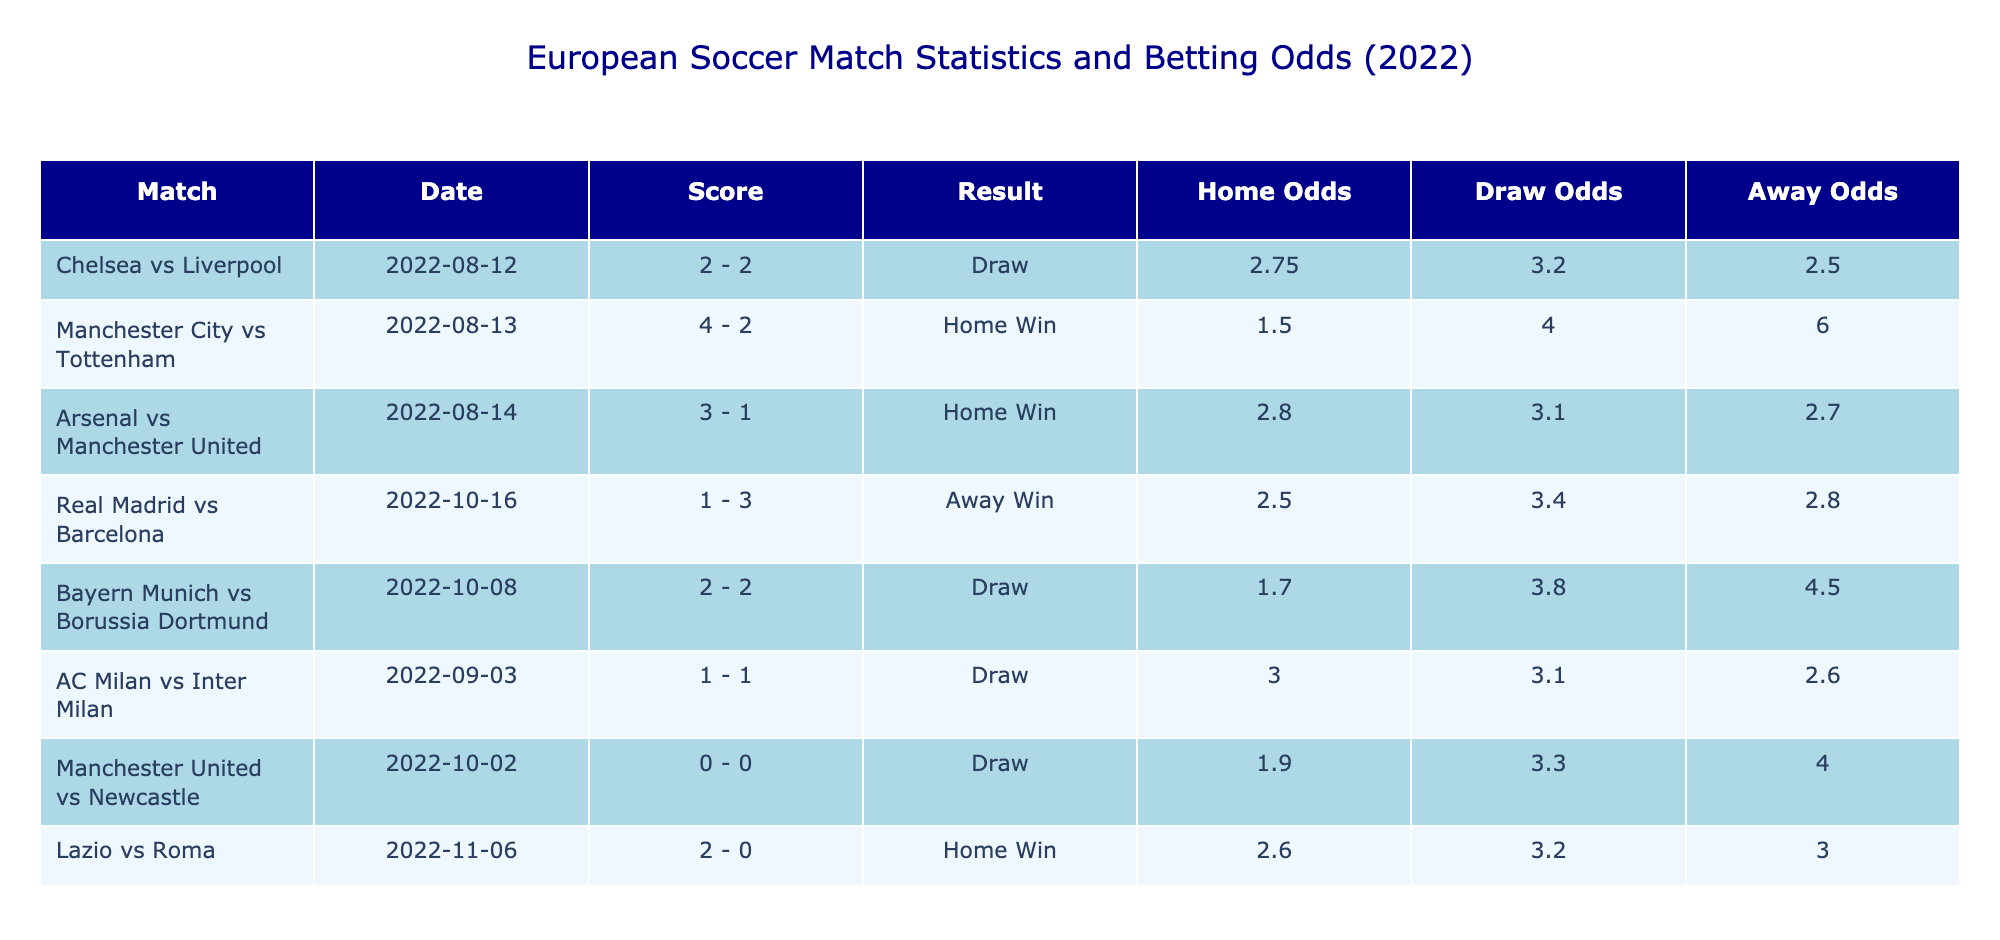What's the score of the match between Chelsea and Liverpool? The table shows the match "Chelsea vs Liverpool" with the home team scoring 2 goals and the away team also scoring 2 goals. Hence, the score is 2 - 2.
Answer: 2 - 2 Which match had the highest home odds? By reviewing the "Home Odds" column, the highest value is 3.00 for the match between AC Milan and Inter Milan.
Answer: 3.00 How many matches ended in a draw? Looking at the "Result" column, there are two matches that ended in a draw: Chelsea vs Liverpool and AC Milan vs Inter Milan.
Answer: 2 What is the average away odds of all the matches listed? To find the average away odds, sum the away odds (2.50 + 6.00 + 2.70 + 2.80 + 4.50 + 2.60 + 4.00 + 3.00) which totals 28.10, then divide by the number of matches (8): 28.10 / 8 = 3.51.
Answer: 3.51 Did Manchester City win against Tottenham? The result for "Manchester City vs Tottenham" shows the home team scored 4 goals while the away team scored 2 goals. Therefore, Manchester City won the match.
Answer: Yes What is the result of the match between Lazio and Roma? In the table, the match "Lazio vs Roma" shows that Lazio scored 2 goals and Roma scored 0 goals, indicating that Lazio won the match.
Answer: Lazio Win Which home team had the least goals scored in their match? In examining the "Home Team Goals" column, Manchester United scored 0 goals against Newcastle, which is the lowest in the dataset.
Answer: Manchester United Was there a match where both teams scored the same number of goals? By checking the scores, the matches "Chelsea vs Liverpool" and "Bayern Munich vs Borussia Dortmund" both ended with the same number of goals scored for each team (2 - 2).
Answer: Yes 